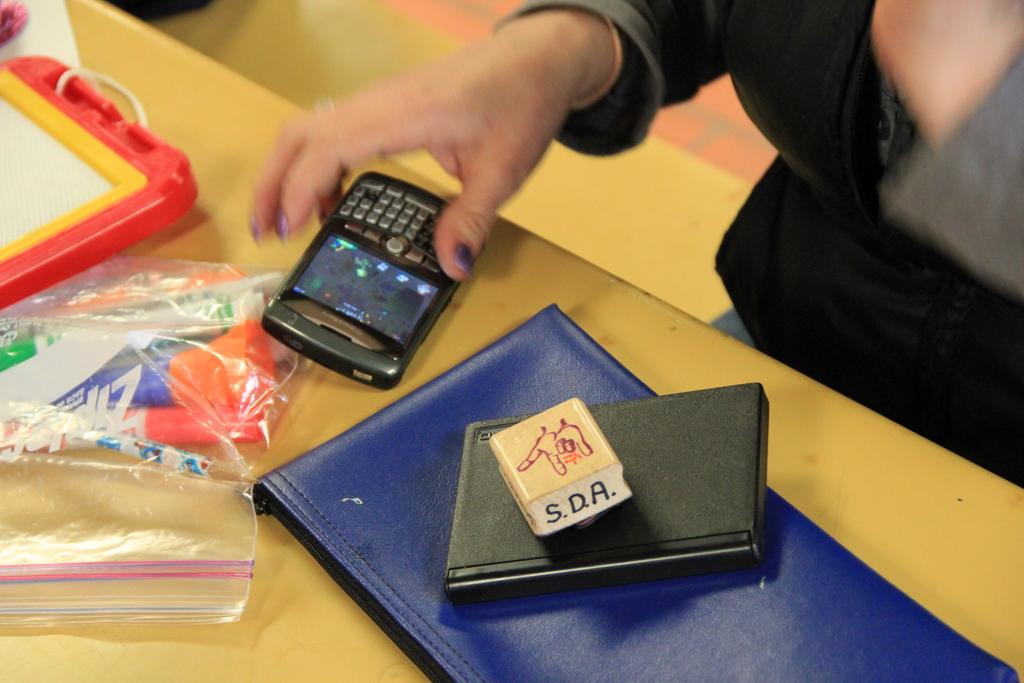What is the brand on the cigarette box?
Provide a short and direct response. Sda. What brand of bag is on the table?
Your answer should be compact. Ziploc. 